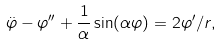<formula> <loc_0><loc_0><loc_500><loc_500>\ddot { \varphi } - \varphi ^ { \prime \prime } + \frac { 1 } { \alpha } \sin ( \alpha \varphi ) = 2 \varphi ^ { \prime } / r ,</formula> 